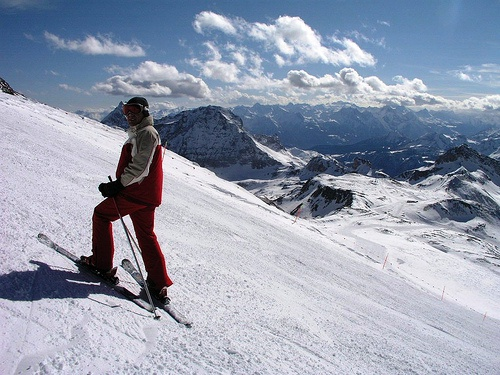Describe the objects in this image and their specific colors. I can see people in blue, black, maroon, gray, and brown tones and skis in blue, gray, black, darkgray, and lightgray tones in this image. 